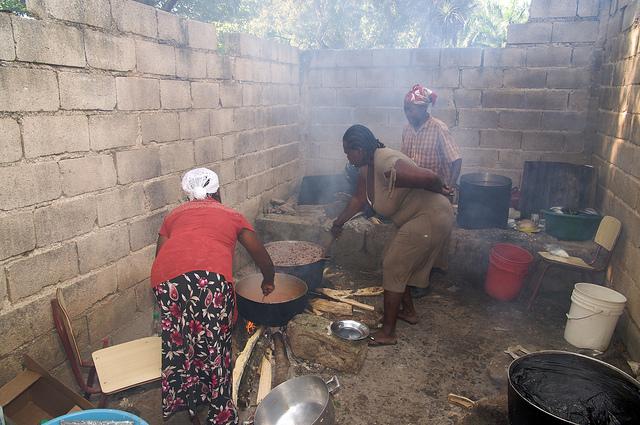Was this picture taken in the USA?
Be succinct. No. What are these people doing?
Write a very short answer. Cooking. Is it smokey here?
Keep it brief. Yes. What country is this?
Keep it brief. Jamaica. 